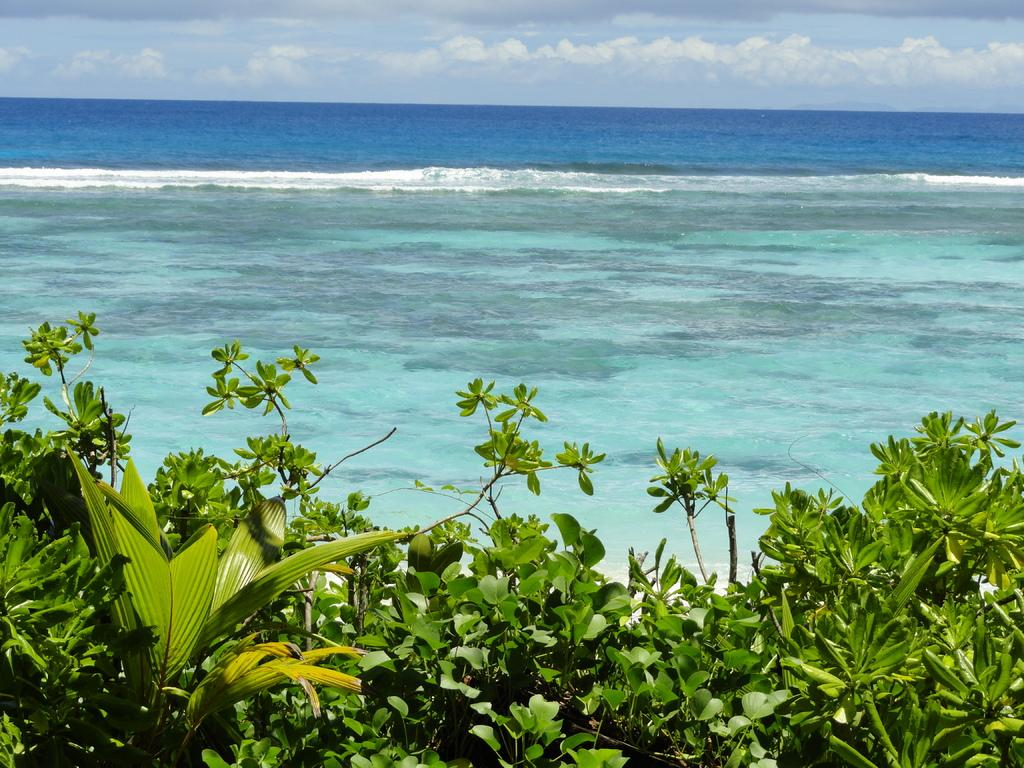What type of vegetation is present in the image? There are green color trees in the image. What natural element can be seen besides the trees? There is water visible in the image. What is visible at the top of the image? The sky is visible at the top of the image. What type of gold can be seen hanging from the trees in the image? There is no gold present in the image; it features green color trees and water. Can you tell me the name of the son who is playing near the water in the image? There is no son present in the image; it only shows trees, water, and the sky. 